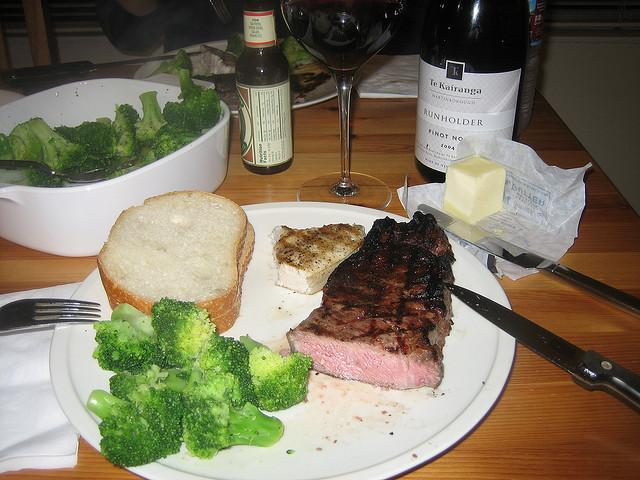How is this steak cooked?

Choices:
A) rare
B) medium
C) well done
D) blue rare medium 